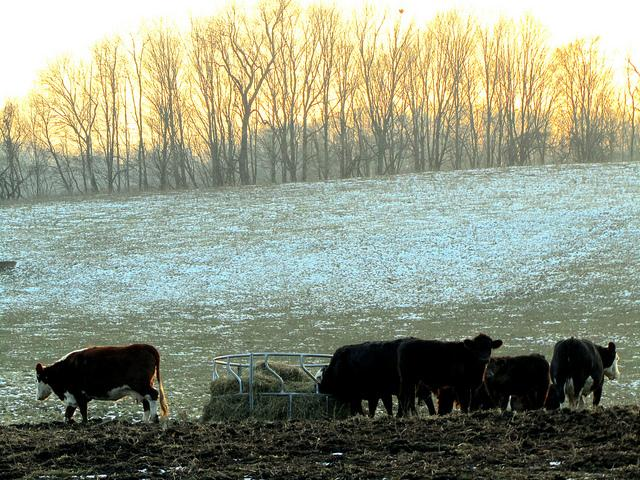What weather event happened recently? snow 